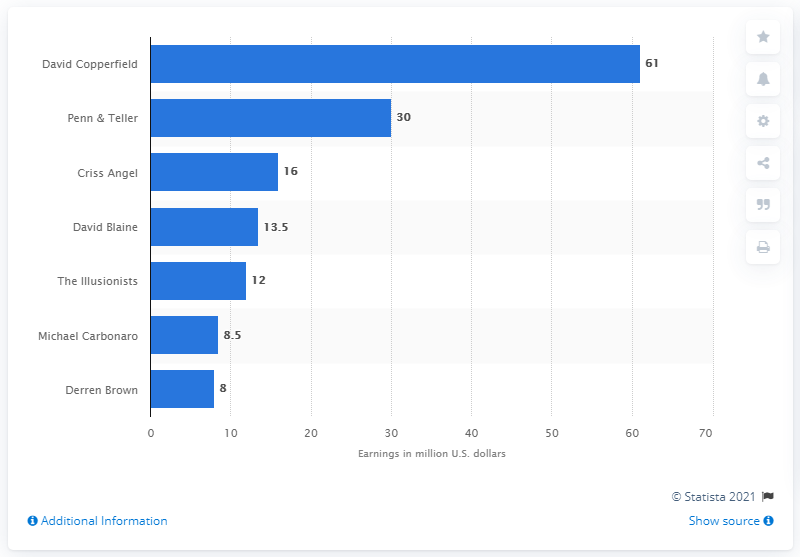Identify some key points in this picture. Derren Brown was the highest paid magician between June 2017 and June 2018. David Copperfield was the highest-paid magician between June 2017 and June 2018. 